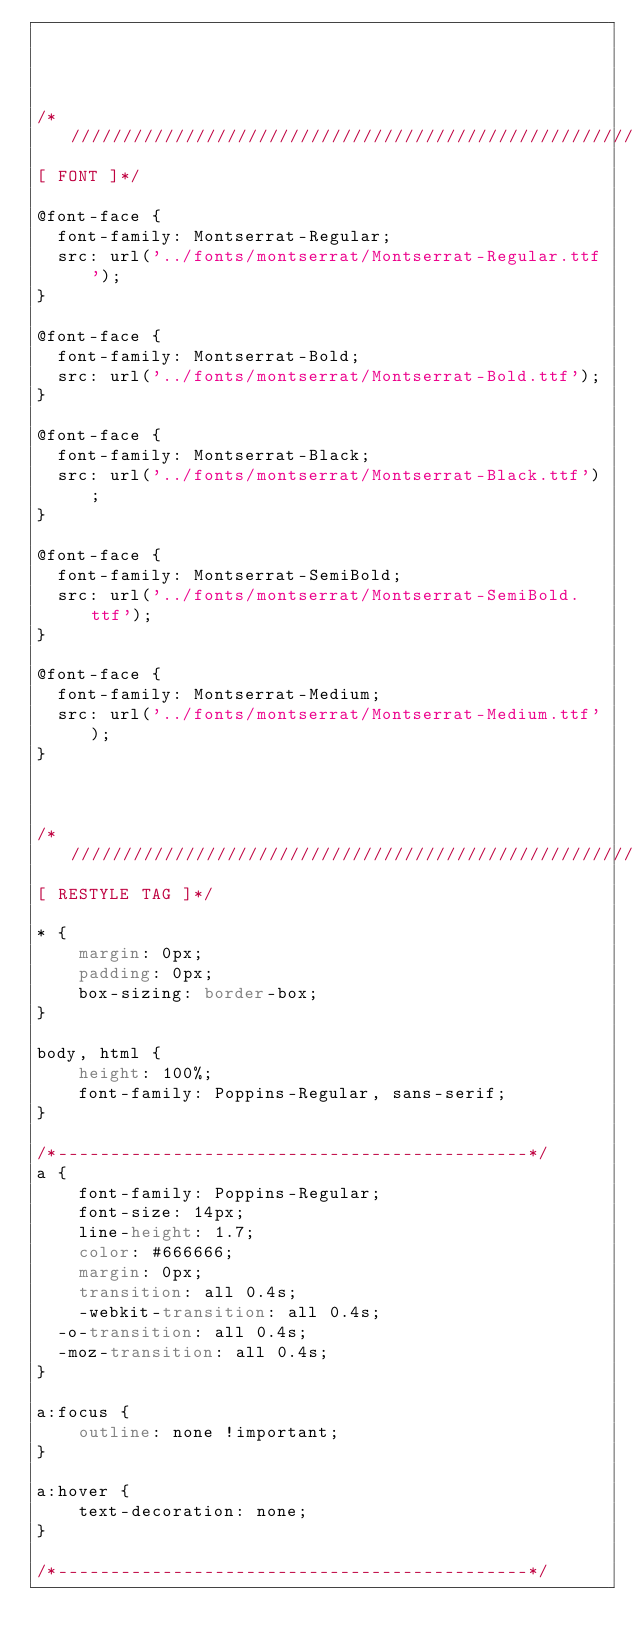<code> <loc_0><loc_0><loc_500><loc_500><_CSS_>



/*//////////////////////////////////////////////////////////////////
[ FONT ]*/

@font-face {
  font-family: Montserrat-Regular;
  src: url('../fonts/montserrat/Montserrat-Regular.ttf');
}

@font-face {
  font-family: Montserrat-Bold;
  src: url('../fonts/montserrat/Montserrat-Bold.ttf');
}

@font-face {
  font-family: Montserrat-Black;
  src: url('../fonts/montserrat/Montserrat-Black.ttf');
}

@font-face {
  font-family: Montserrat-SemiBold;
  src: url('../fonts/montserrat/Montserrat-SemiBold.ttf');
}

@font-face {
  font-family: Montserrat-Medium;
  src: url('../fonts/montserrat/Montserrat-Medium.ttf');
}



/*//////////////////////////////////////////////////////////////////
[ RESTYLE TAG ]*/

* {
	margin: 0px;
	padding: 0px;
	box-sizing: border-box;
}

body, html {
	height: 100%;
	font-family: Poppins-Regular, sans-serif;
}

/*---------------------------------------------*/
a {
	font-family: Poppins-Regular;
	font-size: 14px;
	line-height: 1.7;
	color: #666666;
	margin: 0px;
	transition: all 0.4s;
	-webkit-transition: all 0.4s;
  -o-transition: all 0.4s;
  -moz-transition: all 0.4s;
}

a:focus {
	outline: none !important;
}

a:hover {
	text-decoration: none;
}

/*---------------------------------------------*/</code> 